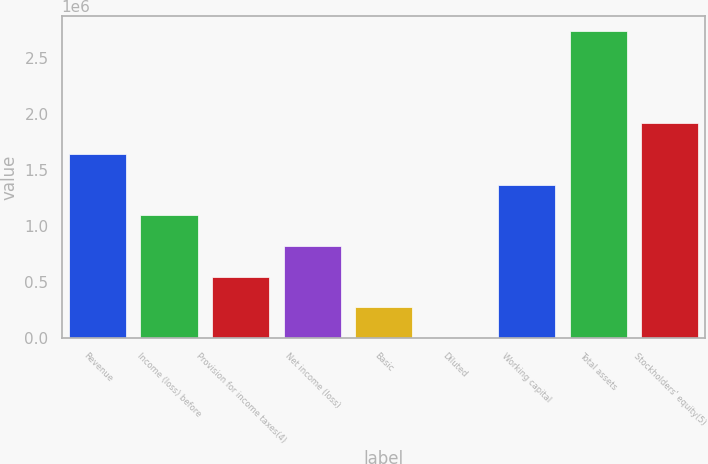Convert chart. <chart><loc_0><loc_0><loc_500><loc_500><bar_chart><fcel>Revenue<fcel>Income (loss) before<fcel>Provision for income taxes(4)<fcel>Net income (loss)<fcel>Basic<fcel>Diluted<fcel>Working capital<fcel>Total assets<fcel>Stockholders' equity(5)<nl><fcel>1.64549e+06<fcel>1.09699e+06<fcel>548497<fcel>822744<fcel>274249<fcel>1.29<fcel>1.37124e+06<fcel>2.74248e+06<fcel>1.91973e+06<nl></chart> 